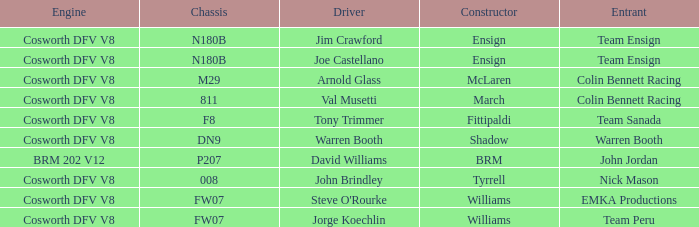What team used the BRM built car? John Jordan. Could you parse the entire table? {'header': ['Engine', 'Chassis', 'Driver', 'Constructor', 'Entrant'], 'rows': [['Cosworth DFV V8', 'N180B', 'Jim Crawford', 'Ensign', 'Team Ensign'], ['Cosworth DFV V8', 'N180B', 'Joe Castellano', 'Ensign', 'Team Ensign'], ['Cosworth DFV V8', 'M29', 'Arnold Glass', 'McLaren', 'Colin Bennett Racing'], ['Cosworth DFV V8', '811', 'Val Musetti', 'March', 'Colin Bennett Racing'], ['Cosworth DFV V8', 'F8', 'Tony Trimmer', 'Fittipaldi', 'Team Sanada'], ['Cosworth DFV V8', 'DN9', 'Warren Booth', 'Shadow', 'Warren Booth'], ['BRM 202 V12', 'P207', 'David Williams', 'BRM', 'John Jordan'], ['Cosworth DFV V8', '008', 'John Brindley', 'Tyrrell', 'Nick Mason'], ['Cosworth DFV V8', 'FW07', "Steve O'Rourke", 'Williams', 'EMKA Productions'], ['Cosworth DFV V8', 'FW07', 'Jorge Koechlin', 'Williams', 'Team Peru']]} 